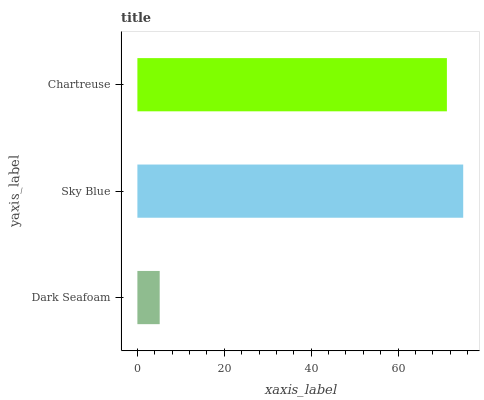Is Dark Seafoam the minimum?
Answer yes or no. Yes. Is Sky Blue the maximum?
Answer yes or no. Yes. Is Chartreuse the minimum?
Answer yes or no. No. Is Chartreuse the maximum?
Answer yes or no. No. Is Sky Blue greater than Chartreuse?
Answer yes or no. Yes. Is Chartreuse less than Sky Blue?
Answer yes or no. Yes. Is Chartreuse greater than Sky Blue?
Answer yes or no. No. Is Sky Blue less than Chartreuse?
Answer yes or no. No. Is Chartreuse the high median?
Answer yes or no. Yes. Is Chartreuse the low median?
Answer yes or no. Yes. Is Sky Blue the high median?
Answer yes or no. No. Is Dark Seafoam the low median?
Answer yes or no. No. 